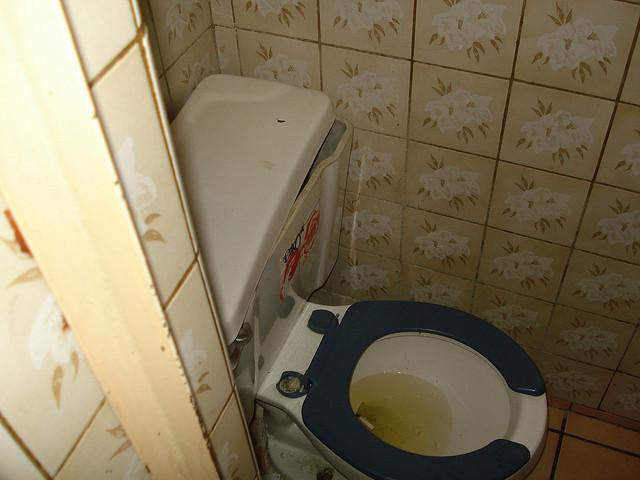What image on each of the tiles?
Write a very short answer. Flowers. Why did you not flush this toilet?
Be succinct. Broken. Is the toilet functional?
Write a very short answer. No. Is there feces in the toilet?
Answer briefly. No. What is in the toilet bowl?
Quick response, please. Urine. What is color of the toilet seat?
Concise answer only. Black. 